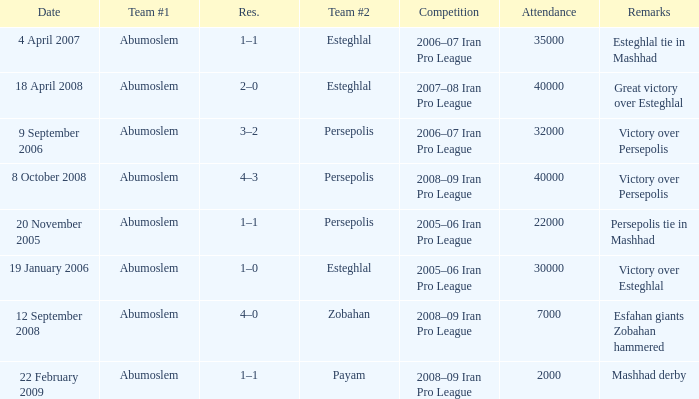I'm looking to parse the entire table for insights. Could you assist me with that? {'header': ['Date', 'Team #1', 'Res.', 'Team #2', 'Competition', 'Attendance', 'Remarks'], 'rows': [['4 April 2007', 'Abumoslem', '1–1', 'Esteghlal', '2006–07 Iran Pro League', '35000', 'Esteghlal tie in Mashhad'], ['18 April 2008', 'Abumoslem', '2–0', 'Esteghlal', '2007–08 Iran Pro League', '40000', 'Great victory over Esteghlal'], ['9 September 2006', 'Abumoslem', '3–2', 'Persepolis', '2006–07 Iran Pro League', '32000', 'Victory over Persepolis'], ['8 October 2008', 'Abumoslem', '4–3', 'Persepolis', '2008–09 Iran Pro League', '40000', 'Victory over Persepolis'], ['20 November 2005', 'Abumoslem', '1–1', 'Persepolis', '2005–06 Iran Pro League', '22000', 'Persepolis tie in Mashhad'], ['19 January 2006', 'Abumoslem', '1–0', 'Esteghlal', '2005–06 Iran Pro League', '30000', 'Victory over Esteghlal'], ['12 September 2008', 'Abumoslem', '4–0', 'Zobahan', '2008–09 Iran Pro League', '7000', 'Esfahan giants Zobahan hammered'], ['22 February 2009', 'Abumoslem', '1–1', 'Payam', '2008–09 Iran Pro League', '2000', 'Mashhad derby']]} What was the largest attendance? 40000.0. 